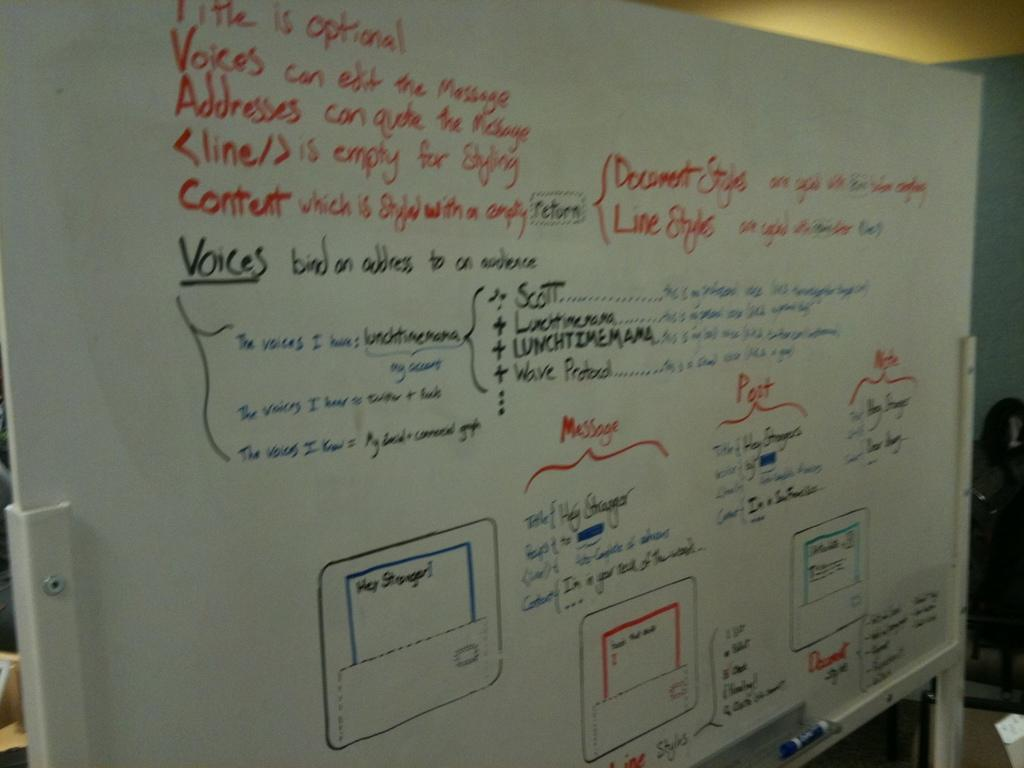<image>
Present a compact description of the photo's key features. a white board with the word voices underlined 